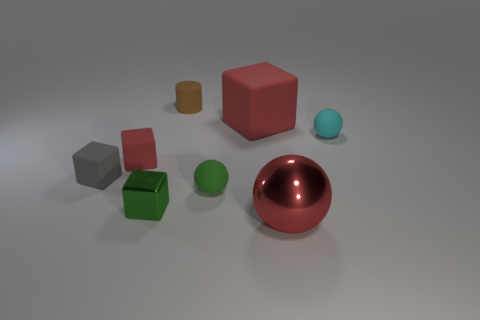There is a metal thing that is on the left side of the brown cylinder; does it have the same size as the big metallic sphere?
Ensure brevity in your answer.  No. Is the number of brown cylinders greater than the number of small yellow spheres?
Your response must be concise. Yes. Are there any small green things that have the same shape as the cyan object?
Provide a short and direct response. Yes. What shape is the green thing right of the green shiny block?
Provide a succinct answer. Sphere. There is a rubber cube on the right side of the tiny matte thing in front of the small gray rubber thing; how many metallic blocks are right of it?
Offer a very short reply. 0. There is a metal thing right of the brown rubber thing; is its color the same as the large cube?
Provide a short and direct response. Yes. How many other objects are there of the same shape as the small cyan object?
Keep it short and to the point. 2. How many other things are made of the same material as the brown cylinder?
Provide a short and direct response. 5. The tiny thing that is in front of the ball to the left of the sphere that is in front of the small metal thing is made of what material?
Offer a very short reply. Metal. Do the small cyan thing and the large red sphere have the same material?
Offer a terse response. No. 